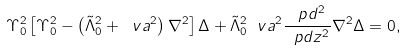Convert formula to latex. <formula><loc_0><loc_0><loc_500><loc_500>\Upsilon ^ { 2 } _ { 0 } \left [ \Upsilon ^ { 2 } _ { 0 } - \left ( \tilde { \Lambda } _ { 0 } ^ { 2 } + \ v a ^ { 2 } \right ) \nabla ^ { 2 } \right ] \Delta + \tilde { \Lambda } _ { 0 } ^ { 2 } \ v a ^ { 2 } \frac { \ p d ^ { 2 } } { \ p d z ^ { 2 } } \nabla ^ { 2 } \Delta = 0 ,</formula> 